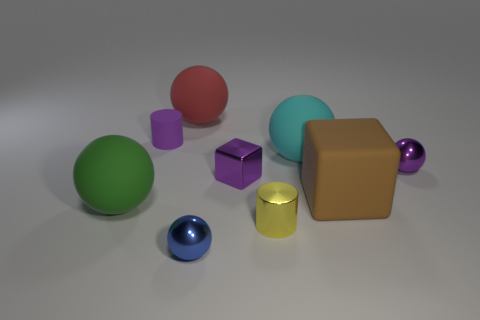Add 1 big brown rubber blocks. How many objects exist? 10 Subtract all purple cubes. Subtract all metal cylinders. How many objects are left? 7 Add 5 big red matte spheres. How many big red matte spheres are left? 6 Add 7 big green matte cylinders. How many big green matte cylinders exist? 7 Subtract all red balls. How many balls are left? 4 Subtract all big cyan spheres. How many spheres are left? 4 Subtract 0 red cylinders. How many objects are left? 9 Subtract all blocks. How many objects are left? 7 Subtract 1 spheres. How many spheres are left? 4 Subtract all cyan cubes. Subtract all red cylinders. How many cubes are left? 2 